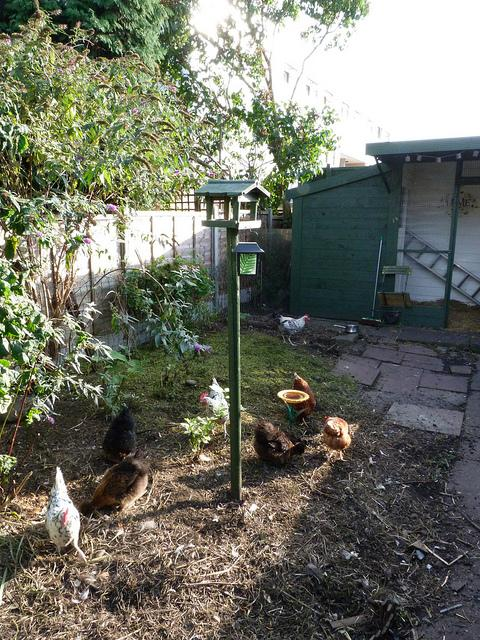How many spotted white chickens are there? three 